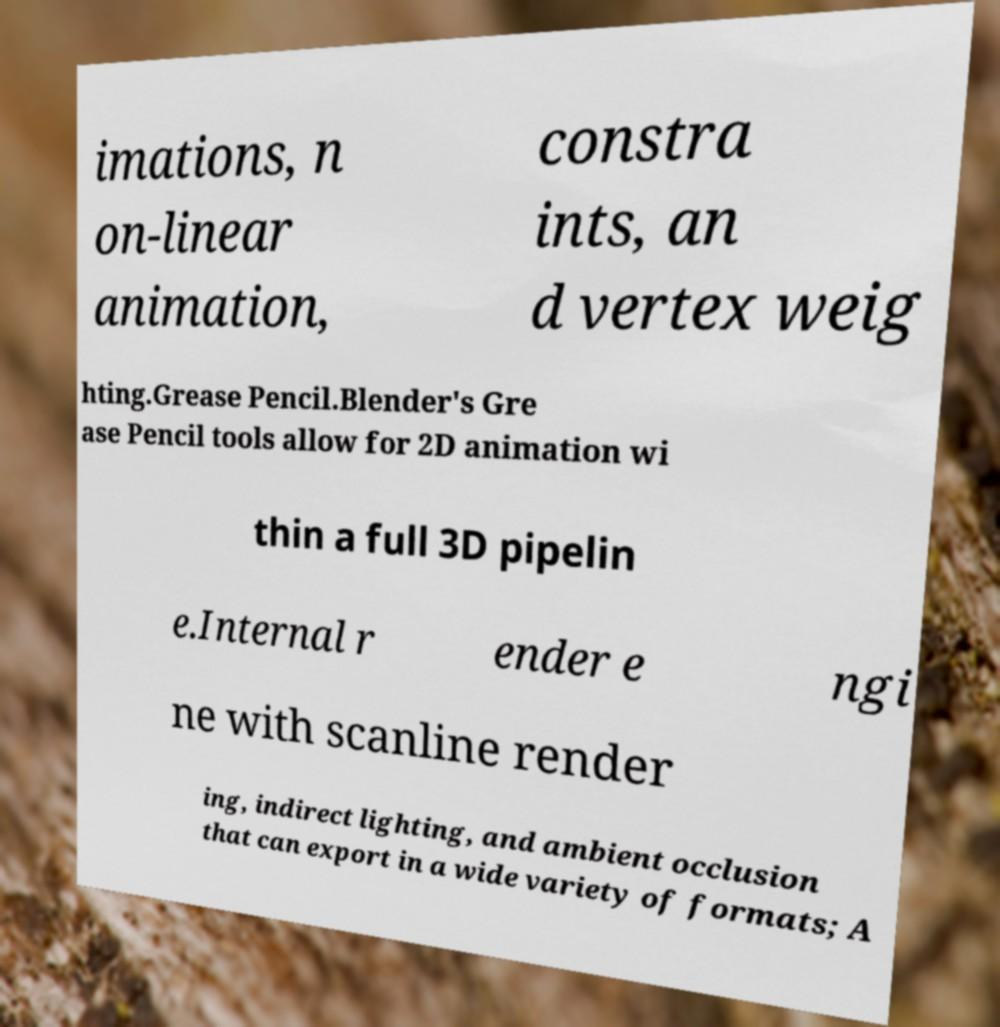I need the written content from this picture converted into text. Can you do that? imations, n on-linear animation, constra ints, an d vertex weig hting.Grease Pencil.Blender's Gre ase Pencil tools allow for 2D animation wi thin a full 3D pipelin e.Internal r ender e ngi ne with scanline render ing, indirect lighting, and ambient occlusion that can export in a wide variety of formats; A 